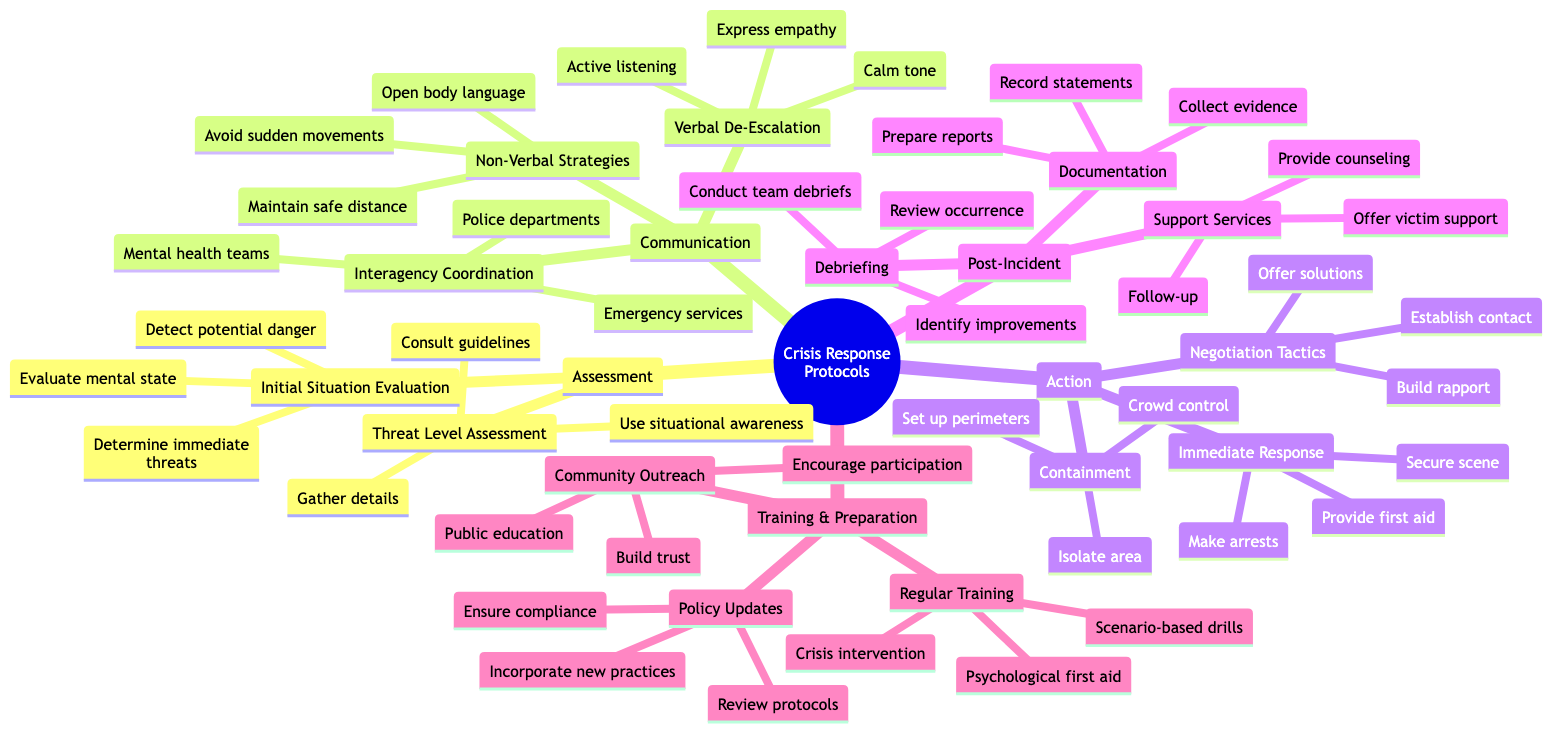What are the two main categories under Crisis Response Protocols? The diagram indicates that "Assessment" and "Communication" are the first two main categories listed under "Crisis Response Protocols."
Answer: Assessment, Communication How many subnodes are under "Action"? Upon examining the "Action" node, we see that it branches out into three subnodes: "Immediate Response," "Containment," and "Negotiation Tactics." Thus, there are three subnodes.
Answer: 3 What is the purpose of the "Debriefing" step in Post-Incident Procedures? The subnode "Debriefing" includes conducting team debriefs, reviewing what occurred, and identifying improvements, which collectively aim to reflect on the incident for better future responses.
Answer: Conduct team debriefs What technique involves maintaining a safe distance? The diagram categorizes this technique under "Non-Verbal Strategies" with a specific mention of "Maintain safe distance," signifying its role in crisis response.
Answer: Maintain safe distance How does "Interagency Coordination" support crisis response? The "Interagency Coordination" section indicates collaboration with "Local police departments," "Mental health crisis teams," and "Emergency medical services," which enhance the effectiveness of the response through cooperation.
Answer: Local police departments What are the three areas of focus in the "Training and Preparation" node? The node "Training and Preparation" splits into three primary areas: "Regular Training," "Policy Updates," and "Community Outreach," highlighting various aspects of preparedness for crises.
Answer: Regular Training, Policy Updates, Community Outreach Which document is essential for Post-Incident Procedures? Within the "Documentation" subtree, it specifies "Prepare detailed reports" as a crucial element, indicating its significance in maintaining accurate records post-incident.
Answer: Prepare detailed reports What action should be taken first according to the “Immediate Response”? The "Immediate Response" section outlines that the first action listed is to "Secure the scene," making it the priority during an immediate crisis intervention.
Answer: Secure the scene What are two skills listed under "Verbal De-Escalation Techniques"? The "Verbal De-Escalation Techniques" node mentions "Active listening" and "Calm tone of voice" as key skills to be employed during interventions, demonstrating effective communication.
Answer: Active listening, Calm tone of voice 